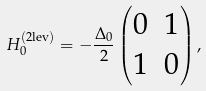<formula> <loc_0><loc_0><loc_500><loc_500>H ^ { ( \text {2lev} ) } _ { 0 } = - \frac { \Delta _ { 0 } } { 2 } \begin{pmatrix} 0 & 1 \\ 1 & 0 \end{pmatrix} ,</formula> 